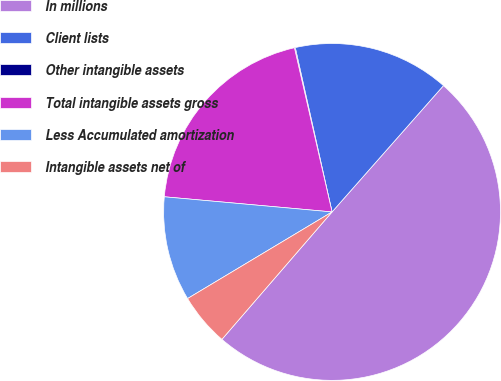Convert chart to OTSL. <chart><loc_0><loc_0><loc_500><loc_500><pie_chart><fcel>In millions<fcel>Client lists<fcel>Other intangible assets<fcel>Total intangible assets gross<fcel>Less Accumulated amortization<fcel>Intangible assets net of<nl><fcel>49.84%<fcel>15.01%<fcel>0.08%<fcel>19.98%<fcel>10.03%<fcel>5.06%<nl></chart> 